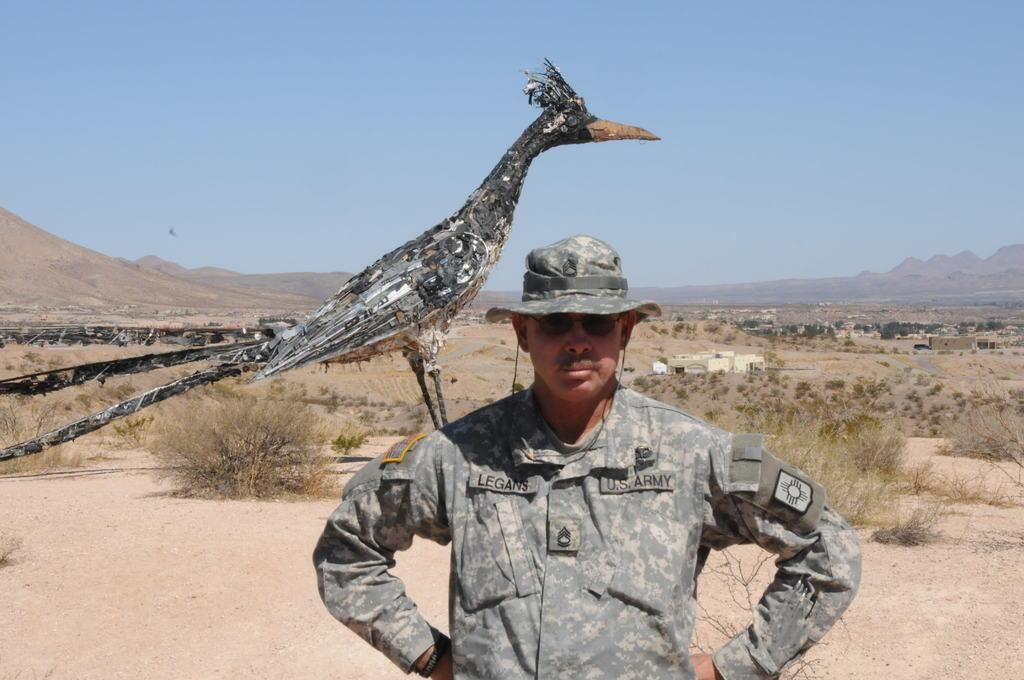What is the main subject of the image? There is a person standing in the image. What can be seen behind the person? There is a bird structure behind the person. What is visible in the background of the image? There are trees, buildings, mountains, and the sky visible in the background of the image. What type of popcorn is being served on the board in the image? There is no popcorn or board present in the image. How is the person transporting themselves in the image? The image does not show the person in motion or using any form of transportation. 